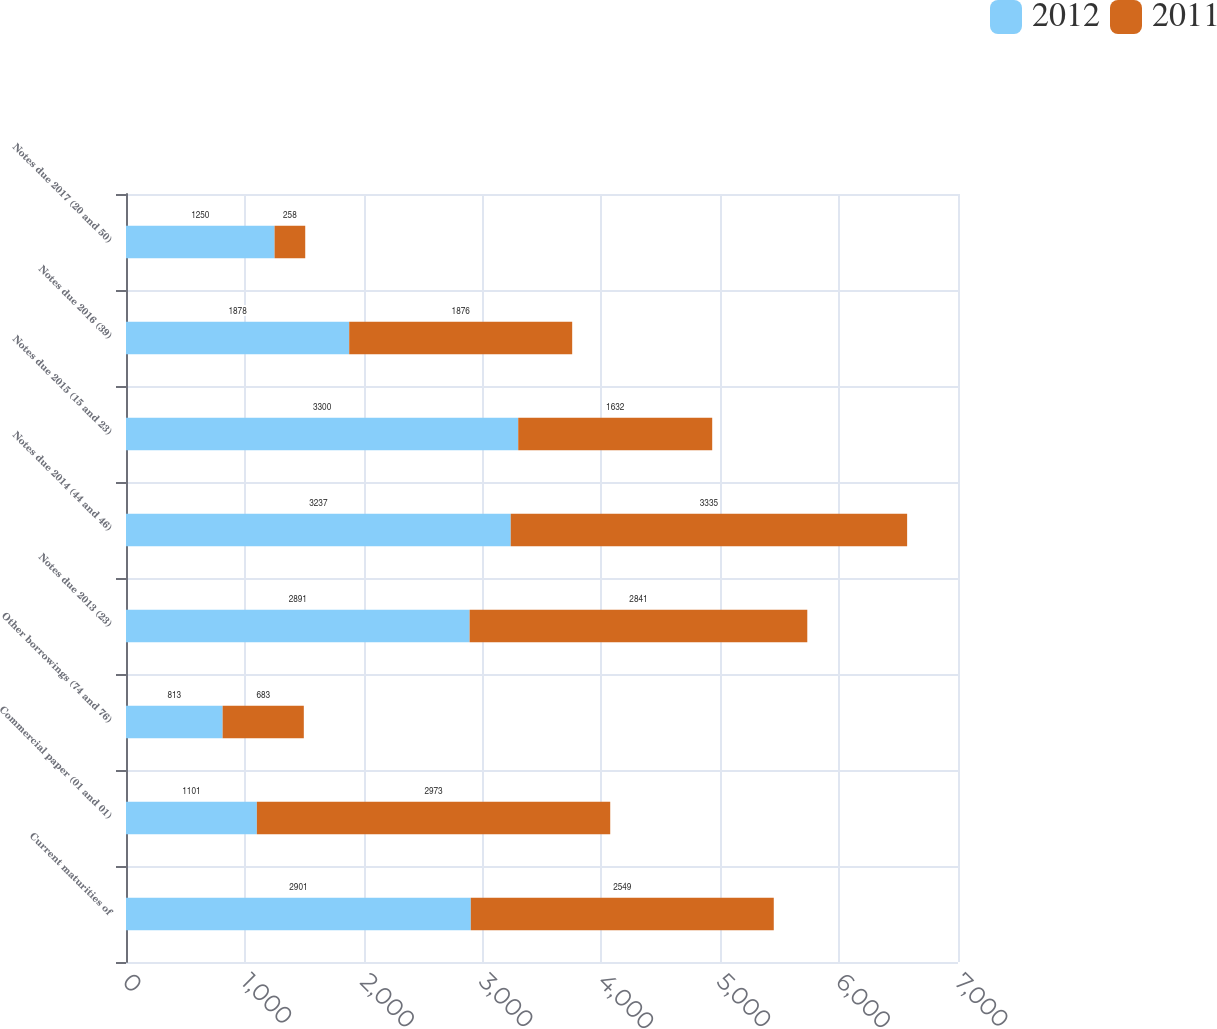Convert chart. <chart><loc_0><loc_0><loc_500><loc_500><stacked_bar_chart><ecel><fcel>Current maturities of<fcel>Commercial paper (01 and 01)<fcel>Other borrowings (74 and 76)<fcel>Notes due 2013 (23)<fcel>Notes due 2014 (44 and 46)<fcel>Notes due 2015 (15 and 23)<fcel>Notes due 2016 (39)<fcel>Notes due 2017 (20 and 50)<nl><fcel>2012<fcel>2901<fcel>1101<fcel>813<fcel>2891<fcel>3237<fcel>3300<fcel>1878<fcel>1250<nl><fcel>2011<fcel>2549<fcel>2973<fcel>683<fcel>2841<fcel>3335<fcel>1632<fcel>1876<fcel>258<nl></chart> 